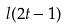<formula> <loc_0><loc_0><loc_500><loc_500>l ( 2 t - 1 )</formula> 